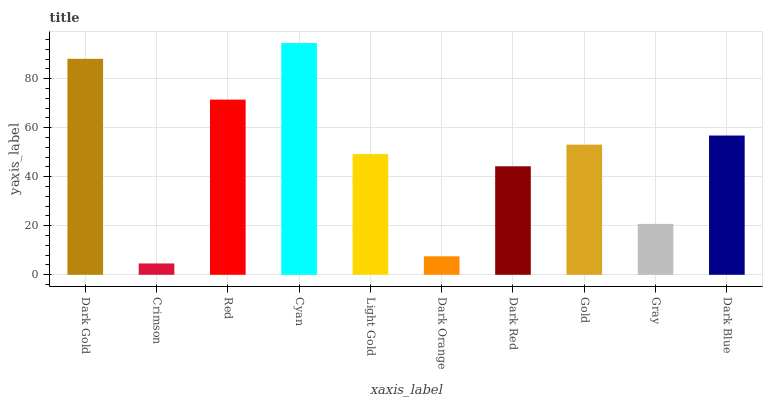Is Red the minimum?
Answer yes or no. No. Is Red the maximum?
Answer yes or no. No. Is Red greater than Crimson?
Answer yes or no. Yes. Is Crimson less than Red?
Answer yes or no. Yes. Is Crimson greater than Red?
Answer yes or no. No. Is Red less than Crimson?
Answer yes or no. No. Is Gold the high median?
Answer yes or no. Yes. Is Light Gold the low median?
Answer yes or no. Yes. Is Light Gold the high median?
Answer yes or no. No. Is Cyan the low median?
Answer yes or no. No. 